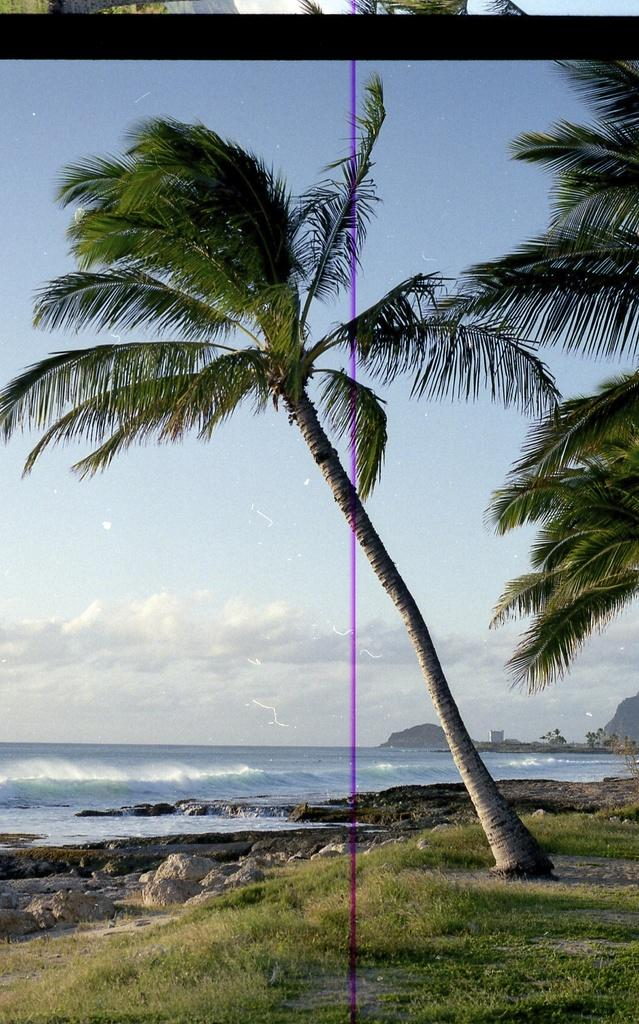What type of vegetation is present in the image? There is a tree and grass in the image. What other natural elements can be seen in the image? There are rocks visible in the image. What can be seen in the background of the image? In the background, there is water, mountains, trees, and the sky. What title is being awarded to the tree in the image? There is no title being awarded to the tree in the image, as it is a photograph and not an event. What record is being set by the rocks in the image? There is no record being set by the rocks in the image, as they are simply a natural element in the scene. 